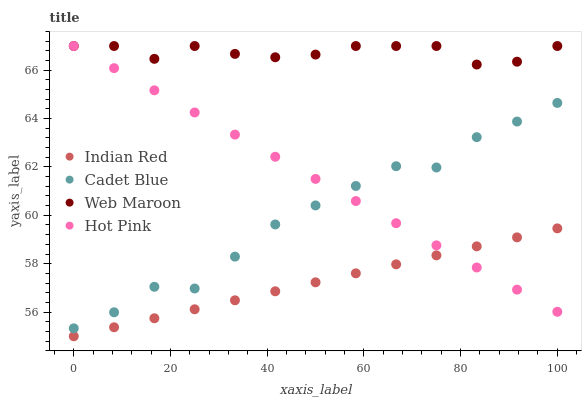Does Indian Red have the minimum area under the curve?
Answer yes or no. Yes. Does Web Maroon have the maximum area under the curve?
Answer yes or no. Yes. Does Web Maroon have the minimum area under the curve?
Answer yes or no. No. Does Indian Red have the maximum area under the curve?
Answer yes or no. No. Is Indian Red the smoothest?
Answer yes or no. Yes. Is Cadet Blue the roughest?
Answer yes or no. Yes. Is Web Maroon the smoothest?
Answer yes or no. No. Is Web Maroon the roughest?
Answer yes or no. No. Does Indian Red have the lowest value?
Answer yes or no. Yes. Does Web Maroon have the lowest value?
Answer yes or no. No. Does Hot Pink have the highest value?
Answer yes or no. Yes. Does Indian Red have the highest value?
Answer yes or no. No. Is Indian Red less than Web Maroon?
Answer yes or no. Yes. Is Web Maroon greater than Cadet Blue?
Answer yes or no. Yes. Does Cadet Blue intersect Hot Pink?
Answer yes or no. Yes. Is Cadet Blue less than Hot Pink?
Answer yes or no. No. Is Cadet Blue greater than Hot Pink?
Answer yes or no. No. Does Indian Red intersect Web Maroon?
Answer yes or no. No. 